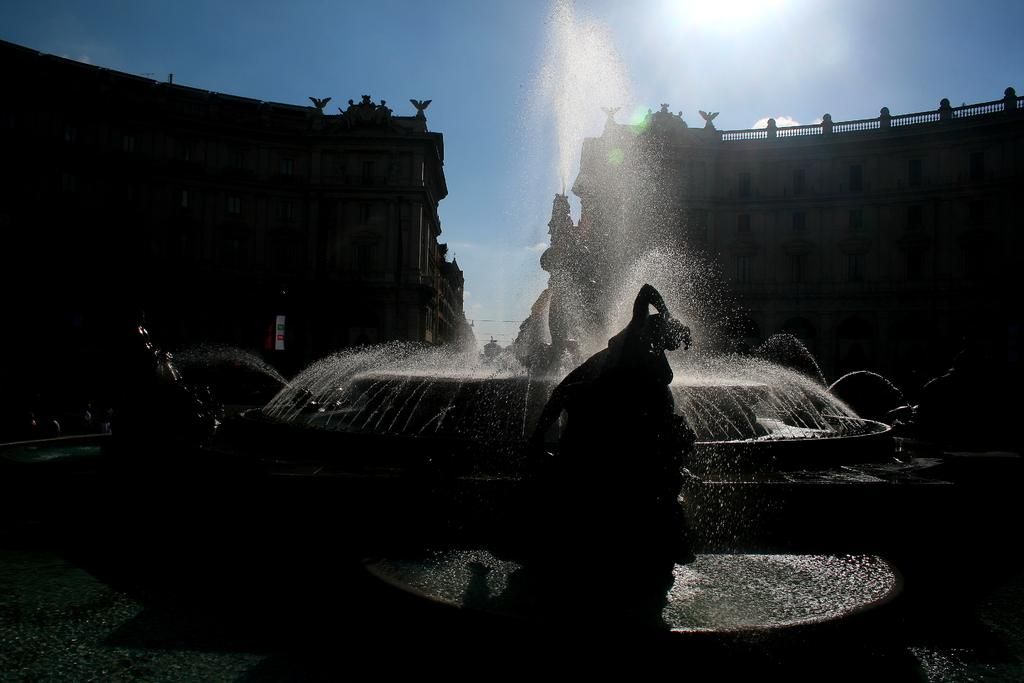What type of structures can be seen in the image? There are buildings in the image. What is the central feature in the image? There is a fountain in the image. Are there any other notable objects or features in the image? Yes, there is a statue in the image. What is visible at the top of the image? The sky is visible at the top of the image. How would you describe the lighting in the image? The image appears to be slightly dark. How many cherries are on the statue in the image? There are no cherries present on the statue in the image. What is the cause of death for the person depicted in the statue? There is no person depicted in the statue, and therefore no cause of death can be determined. 